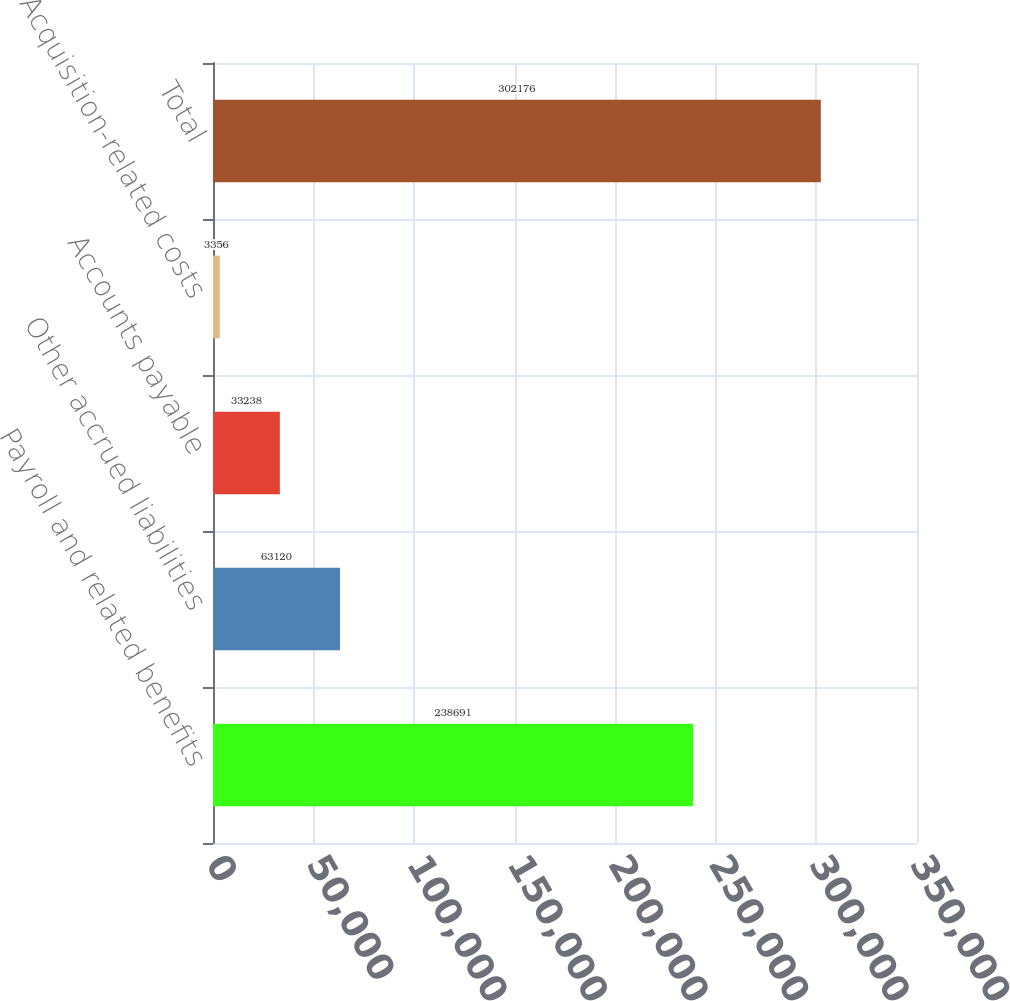Convert chart to OTSL. <chart><loc_0><loc_0><loc_500><loc_500><bar_chart><fcel>Payroll and related benefits<fcel>Other accrued liabilities<fcel>Accounts payable<fcel>Acquisition-related costs<fcel>Total<nl><fcel>238691<fcel>63120<fcel>33238<fcel>3356<fcel>302176<nl></chart> 